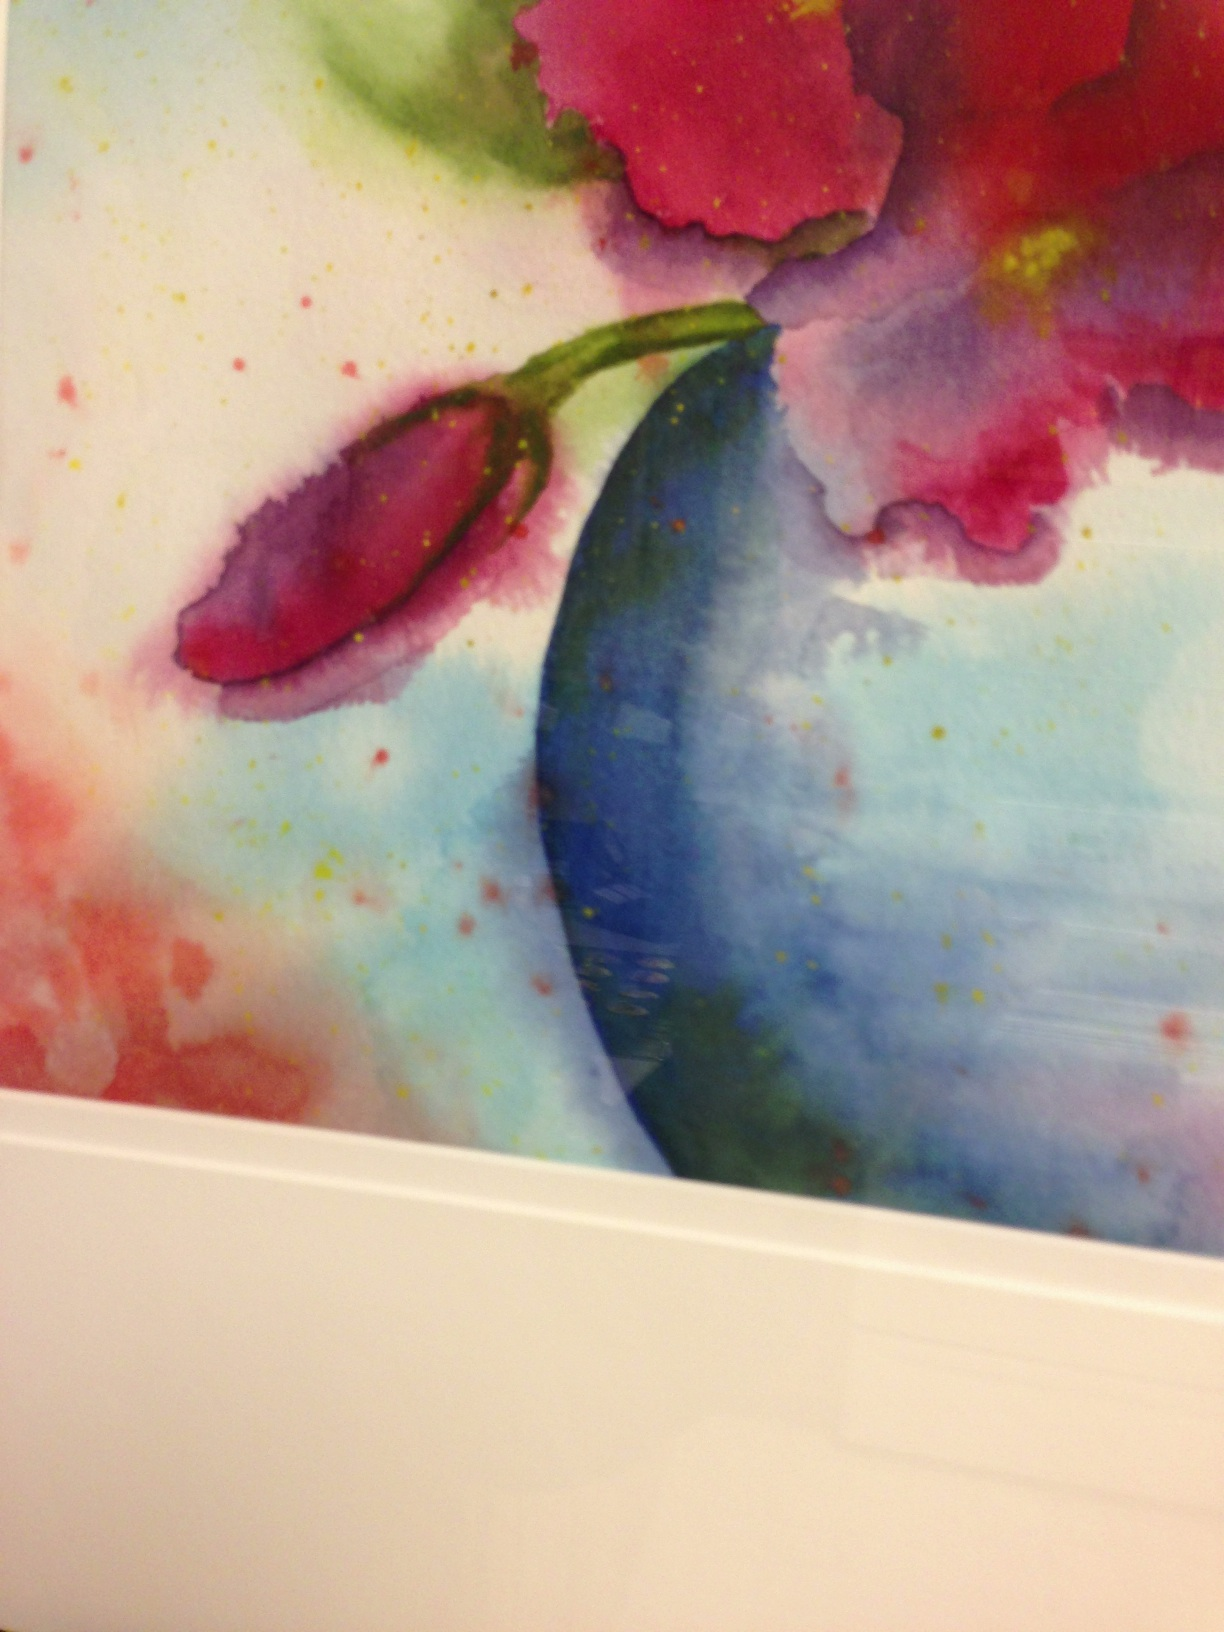Can you describe the techniques that might have been used to create the textures and color gradients in this watercolor painting? The artist likely utilized techniques such as wet-on-wet watercolor painting, where watercolor is applied onto a damp surface to create a soft, diffused effect in the colors and textures. Additionally, the splattering technique might have been used to create the specks of color, adding to the painting's liveliness and texture. 